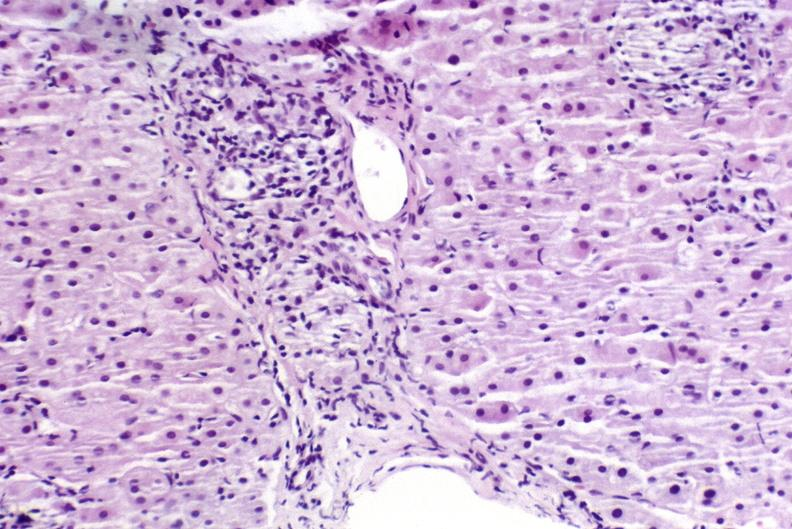does this image show sarcoid?
Answer the question using a single word or phrase. Yes 